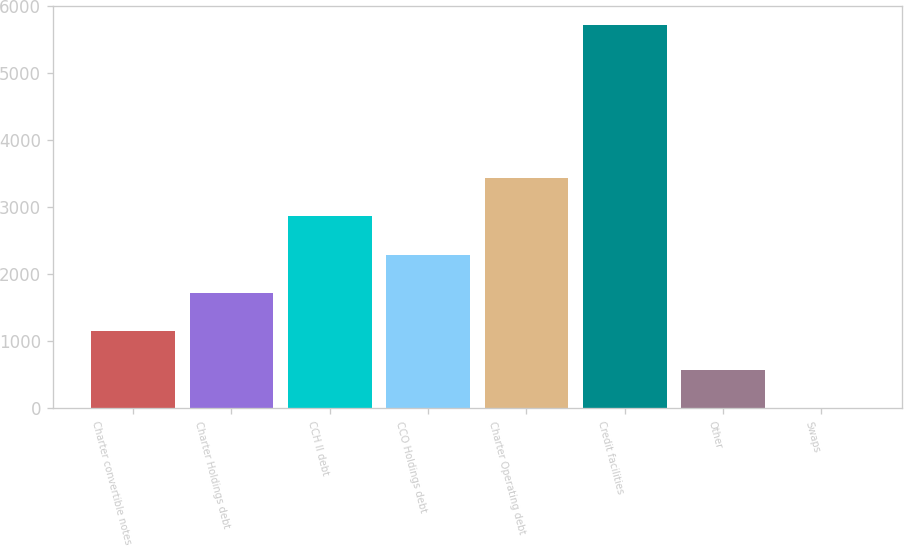Convert chart. <chart><loc_0><loc_0><loc_500><loc_500><bar_chart><fcel>Charter convertible notes<fcel>Charter Holdings debt<fcel>CCH II debt<fcel>CCO Holdings debt<fcel>Charter Operating debt<fcel>Credit facilities<fcel>Other<fcel>Swaps<nl><fcel>1147<fcel>1718.5<fcel>2861.5<fcel>2290<fcel>3433<fcel>5719<fcel>575.5<fcel>4<nl></chart> 